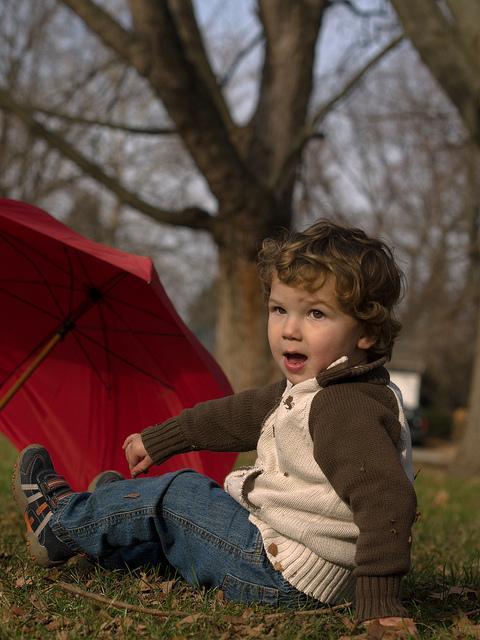Does the caption "The umbrella is alongside the person." correctly depict the image?
Answer yes or no. Yes. Is the caption "The umbrella is over the person." a true representation of the image?
Answer yes or no. No. 